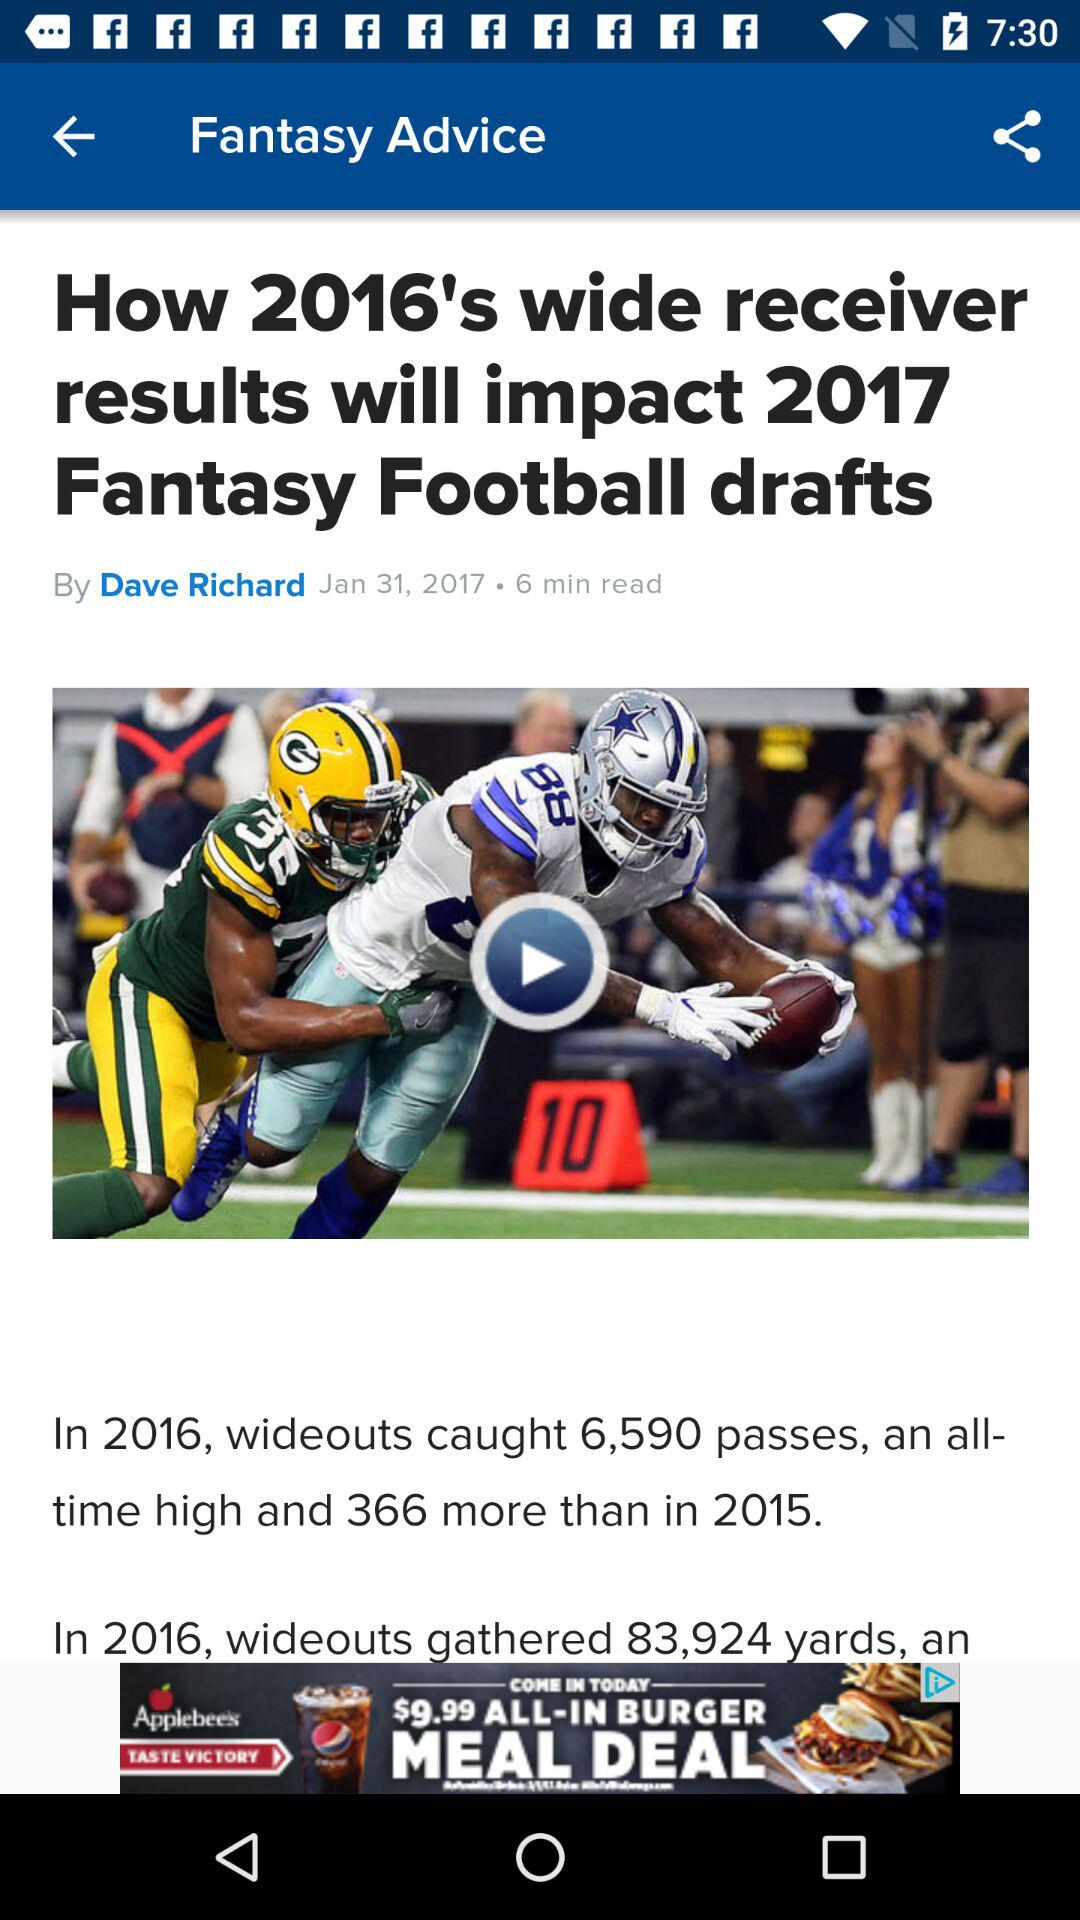Can you tell me what significant statistics are mentioned in the article shown in the image? Certainly, the image contains key statistics from the article, which mentions that wide receivers caught 6,590 passes in 2016, a record high for the season, and this was 366 more than in 2015. Additionally, it notes that wideouts gathered 83,924 yards, indicating a prolific output in receiving yards as well. 